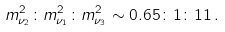<formula> <loc_0><loc_0><loc_500><loc_500>m ^ { 2 } _ { \nu _ { 2 } } \colon m ^ { 2 } _ { \nu _ { 1 } } \colon m ^ { 2 } _ { \nu _ { 3 } } \sim 0 . 6 5 \colon 1 \colon 1 1 \, .</formula> 